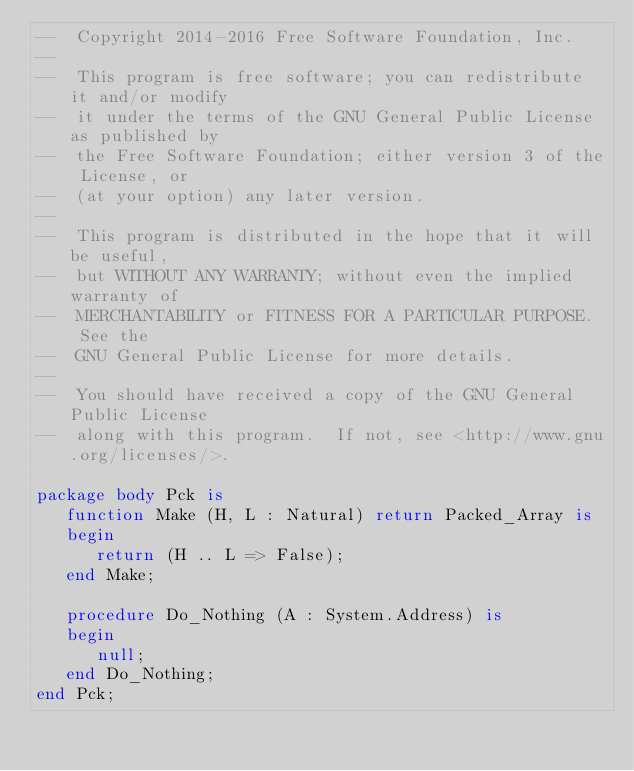Convert code to text. <code><loc_0><loc_0><loc_500><loc_500><_Ada_>--  Copyright 2014-2016 Free Software Foundation, Inc.
--
--  This program is free software; you can redistribute it and/or modify
--  it under the terms of the GNU General Public License as published by
--  the Free Software Foundation; either version 3 of the License, or
--  (at your option) any later version.
--
--  This program is distributed in the hope that it will be useful,
--  but WITHOUT ANY WARRANTY; without even the implied warranty of
--  MERCHANTABILITY or FITNESS FOR A PARTICULAR PURPOSE.  See the
--  GNU General Public License for more details.
--
--  You should have received a copy of the GNU General Public License
--  along with this program.  If not, see <http://www.gnu.org/licenses/>.

package body Pck is
   function Make (H, L : Natural) return Packed_Array is
   begin
      return (H .. L => False);
   end Make;

   procedure Do_Nothing (A : System.Address) is
   begin
      null;
   end Do_Nothing;
end Pck;
</code> 